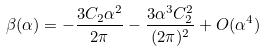Convert formula to latex. <formula><loc_0><loc_0><loc_500><loc_500>\beta ( \alpha ) = - \frac { 3 C _ { 2 } \alpha ^ { 2 } } { 2 \pi } - \frac { 3 \alpha ^ { 3 } C _ { 2 } ^ { 2 } } { ( 2 \pi ) ^ { 2 } } + O ( \alpha ^ { 4 } )</formula> 